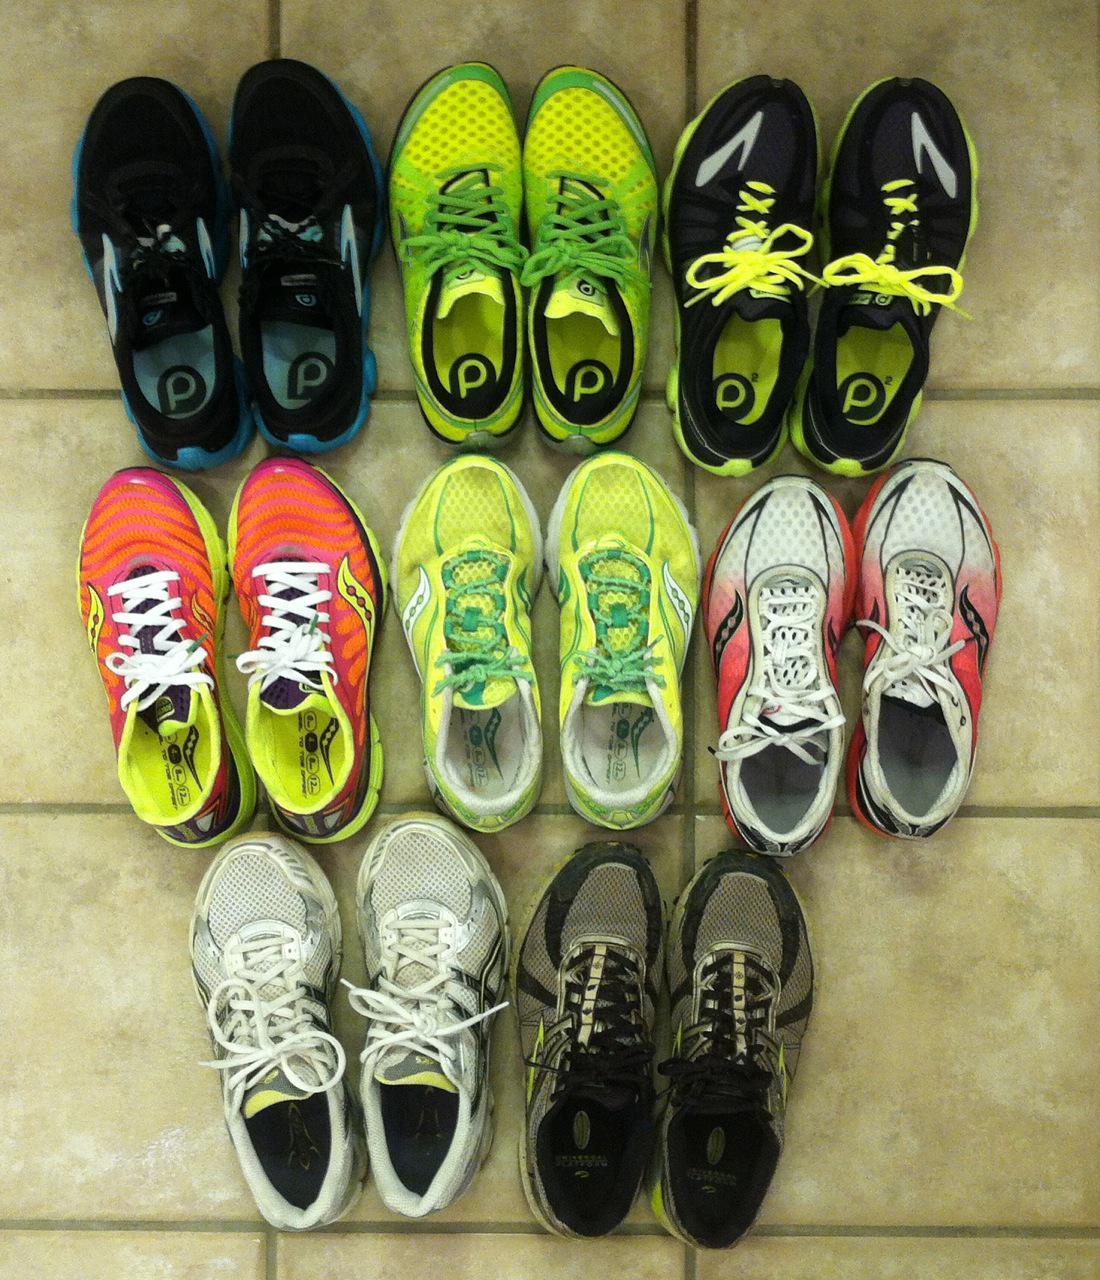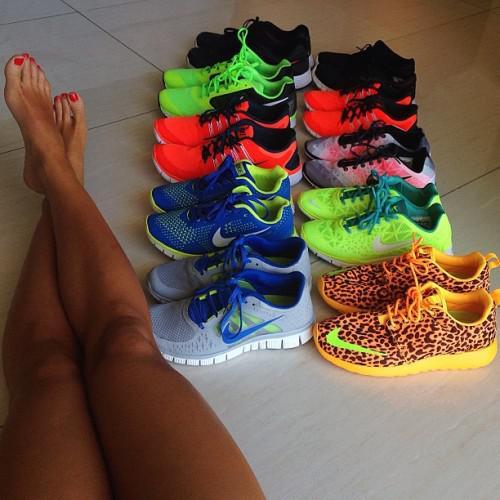The first image is the image on the left, the second image is the image on the right. For the images shown, is this caption "No more than three sneakers are visible in the left image." true? Answer yes or no. No. The first image is the image on the left, the second image is the image on the right. Considering the images on both sides, is "One of the images features no more than three shoes." valid? Answer yes or no. No. 